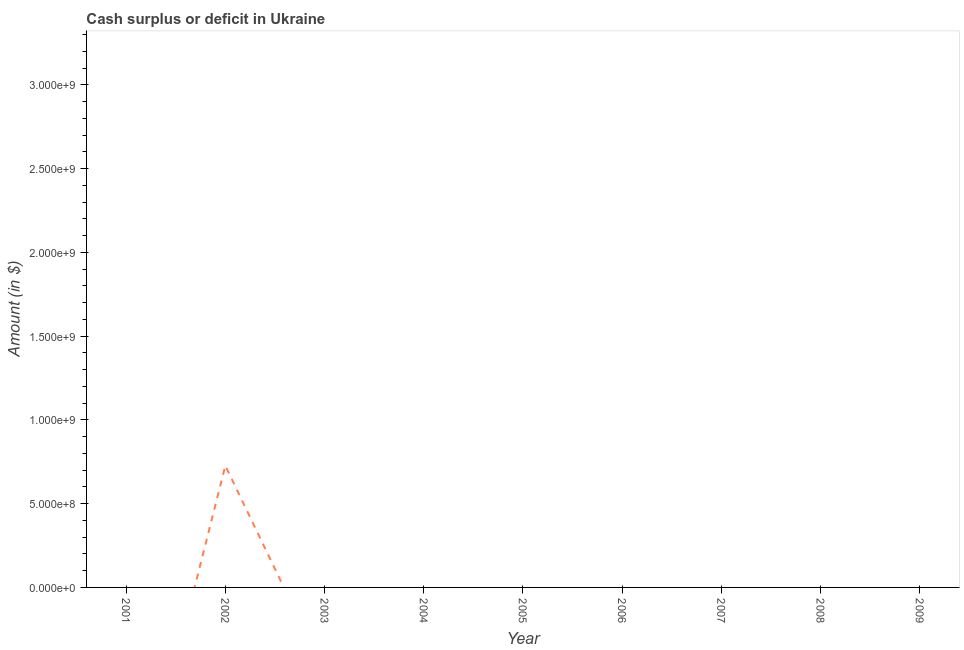Across all years, what is the maximum cash surplus or deficit?
Your response must be concise. 7.27e+08. Across all years, what is the minimum cash surplus or deficit?
Provide a succinct answer. 0. In which year was the cash surplus or deficit maximum?
Provide a succinct answer. 2002. What is the sum of the cash surplus or deficit?
Make the answer very short. 7.27e+08. What is the average cash surplus or deficit per year?
Give a very brief answer. 8.08e+07. What is the median cash surplus or deficit?
Offer a terse response. 0. In how many years, is the cash surplus or deficit greater than 1500000000 $?
Provide a succinct answer. 0. What is the difference between the highest and the lowest cash surplus or deficit?
Offer a terse response. 7.27e+08. In how many years, is the cash surplus or deficit greater than the average cash surplus or deficit taken over all years?
Make the answer very short. 1. How many lines are there?
Ensure brevity in your answer.  1. How many years are there in the graph?
Give a very brief answer. 9. What is the difference between two consecutive major ticks on the Y-axis?
Keep it short and to the point. 5.00e+08. Does the graph contain any zero values?
Your response must be concise. Yes. Does the graph contain grids?
Provide a succinct answer. No. What is the title of the graph?
Your answer should be very brief. Cash surplus or deficit in Ukraine. What is the label or title of the X-axis?
Give a very brief answer. Year. What is the label or title of the Y-axis?
Offer a terse response. Amount (in $). What is the Amount (in $) in 2002?
Provide a short and direct response. 7.27e+08. What is the Amount (in $) of 2005?
Offer a very short reply. 0. What is the Amount (in $) of 2006?
Keep it short and to the point. 0. 